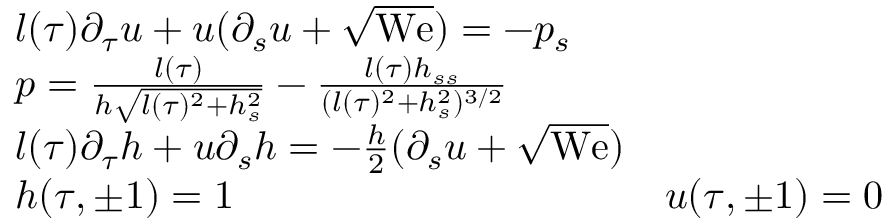Convert formula to latex. <formula><loc_0><loc_0><loc_500><loc_500>\begin{array} { r l r } & { l ( \tau ) \partial _ { \tau } u + u ( \partial _ { s } u + \sqrt { W e } ) = - p _ { s } } \\ & { p = \frac { l ( \tau ) } { h \sqrt { l ( \tau ) ^ { 2 } + h _ { s } ^ { 2 } } } - \frac { l ( \tau ) h _ { s s } } { ( l ( \tau ) ^ { 2 } + h _ { s } ^ { 2 } ) ^ { 3 / 2 } } } \\ & { l ( \tau ) \partial _ { \tau } h + u \partial _ { s } h = - \frac { h } { 2 } ( \partial _ { s } u + \sqrt { W e } ) } \\ & { h ( \tau , \pm 1 ) = 1 \quad } & { u ( \tau , \pm 1 ) = 0 } \end{array}</formula> 